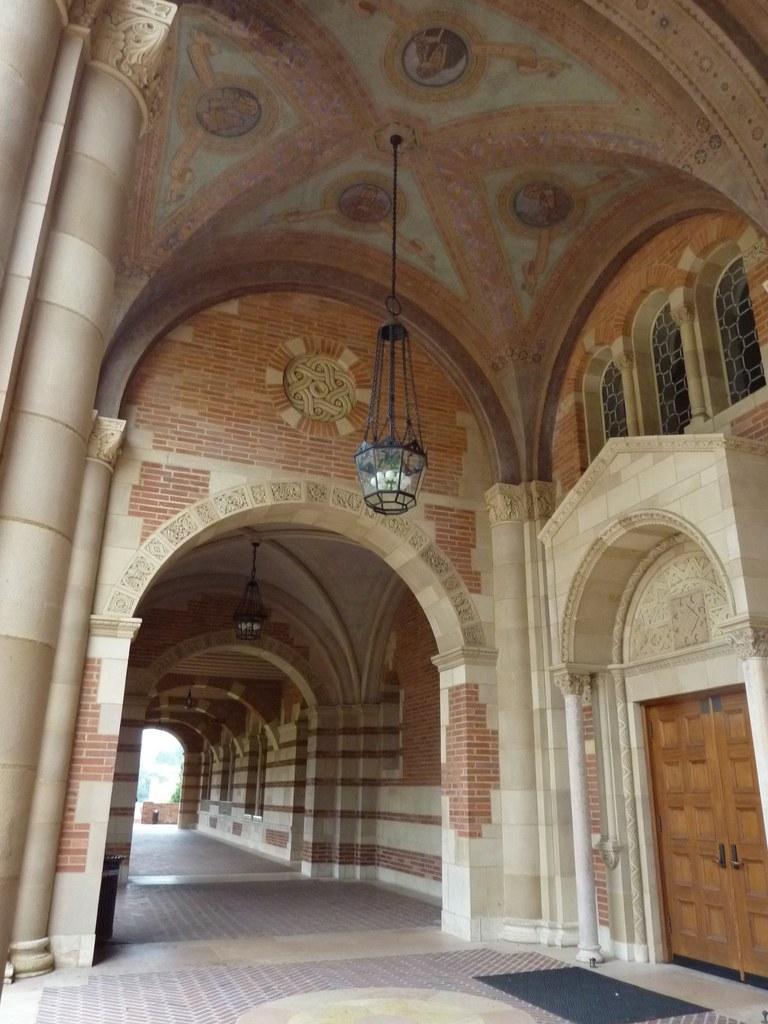Please provide a concise description of this image. In this picture we can see a building, few lights and doors. 